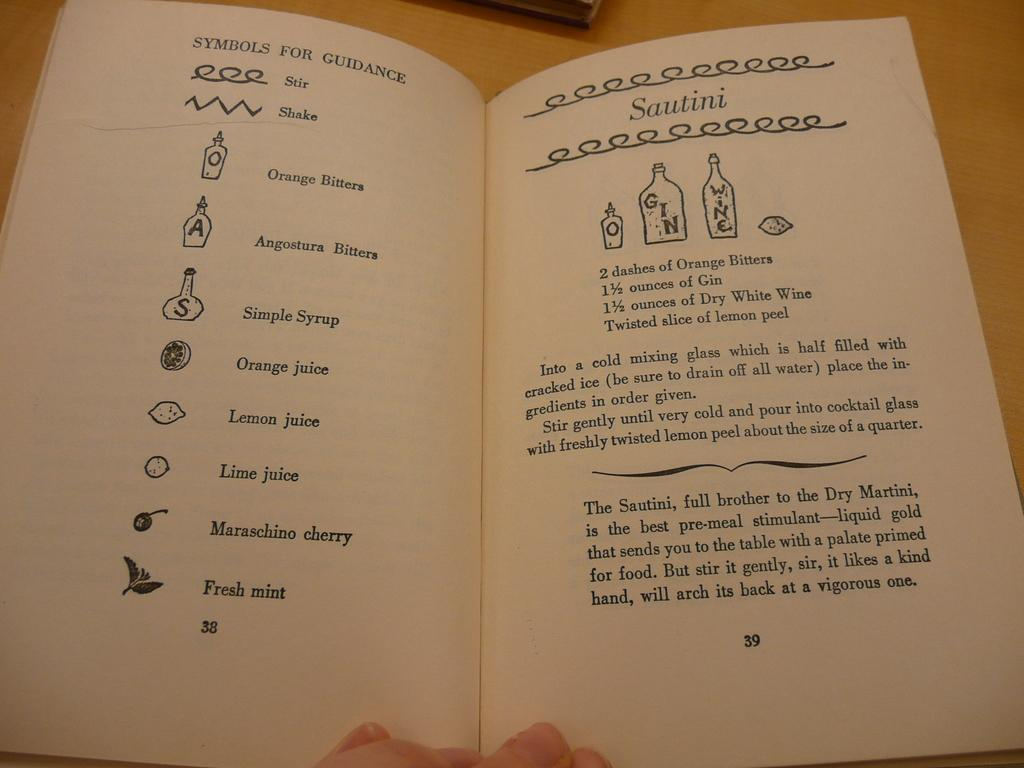<image>
Share a concise interpretation of the image provided. A recipe for Sautini calls for gin and dry white wine. 